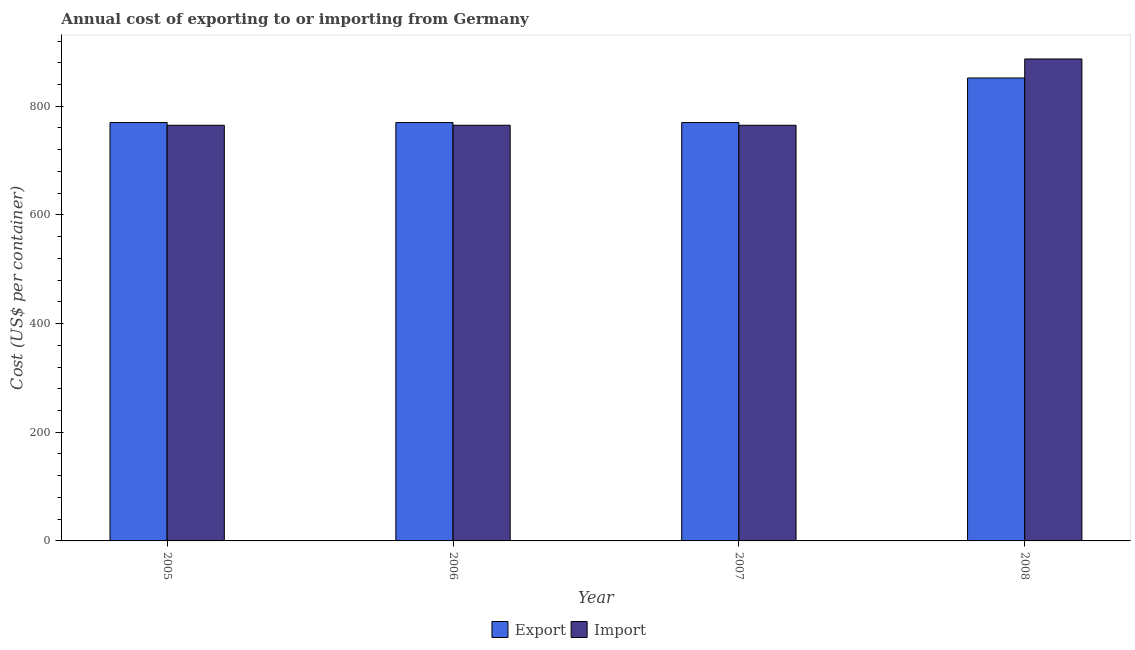Are the number of bars per tick equal to the number of legend labels?
Provide a short and direct response. Yes. What is the label of the 3rd group of bars from the left?
Offer a very short reply. 2007. What is the import cost in 2005?
Provide a succinct answer. 765. Across all years, what is the maximum export cost?
Offer a terse response. 852. Across all years, what is the minimum export cost?
Give a very brief answer. 770. In which year was the export cost minimum?
Give a very brief answer. 2005. What is the total import cost in the graph?
Ensure brevity in your answer.  3182. What is the difference between the export cost in 2005 and that in 2008?
Your response must be concise. -82. What is the difference between the export cost in 2008 and the import cost in 2007?
Provide a short and direct response. 82. What is the average import cost per year?
Provide a succinct answer. 795.5. In how many years, is the import cost greater than 520 US$?
Offer a very short reply. 4. What is the ratio of the export cost in 2006 to that in 2008?
Your answer should be compact. 0.9. What is the difference between the highest and the second highest import cost?
Your answer should be very brief. 122. What is the difference between the highest and the lowest import cost?
Provide a short and direct response. 122. In how many years, is the export cost greater than the average export cost taken over all years?
Offer a very short reply. 1. What does the 1st bar from the left in 2008 represents?
Give a very brief answer. Export. What does the 1st bar from the right in 2008 represents?
Give a very brief answer. Import. How many bars are there?
Give a very brief answer. 8. What is the difference between two consecutive major ticks on the Y-axis?
Your answer should be compact. 200. Does the graph contain grids?
Your answer should be very brief. No. What is the title of the graph?
Provide a short and direct response. Annual cost of exporting to or importing from Germany. Does "Lowest 20% of population" appear as one of the legend labels in the graph?
Provide a short and direct response. No. What is the label or title of the X-axis?
Keep it short and to the point. Year. What is the label or title of the Y-axis?
Provide a succinct answer. Cost (US$ per container). What is the Cost (US$ per container) in Export in 2005?
Keep it short and to the point. 770. What is the Cost (US$ per container) in Import in 2005?
Offer a terse response. 765. What is the Cost (US$ per container) of Export in 2006?
Make the answer very short. 770. What is the Cost (US$ per container) of Import in 2006?
Provide a short and direct response. 765. What is the Cost (US$ per container) of Export in 2007?
Keep it short and to the point. 770. What is the Cost (US$ per container) in Import in 2007?
Keep it short and to the point. 765. What is the Cost (US$ per container) of Export in 2008?
Give a very brief answer. 852. What is the Cost (US$ per container) in Import in 2008?
Offer a terse response. 887. Across all years, what is the maximum Cost (US$ per container) of Export?
Provide a short and direct response. 852. Across all years, what is the maximum Cost (US$ per container) of Import?
Provide a succinct answer. 887. Across all years, what is the minimum Cost (US$ per container) of Export?
Offer a very short reply. 770. Across all years, what is the minimum Cost (US$ per container) in Import?
Your response must be concise. 765. What is the total Cost (US$ per container) of Export in the graph?
Keep it short and to the point. 3162. What is the total Cost (US$ per container) of Import in the graph?
Make the answer very short. 3182. What is the difference between the Cost (US$ per container) of Export in 2005 and that in 2006?
Ensure brevity in your answer.  0. What is the difference between the Cost (US$ per container) in Import in 2005 and that in 2007?
Offer a very short reply. 0. What is the difference between the Cost (US$ per container) in Export in 2005 and that in 2008?
Make the answer very short. -82. What is the difference between the Cost (US$ per container) of Import in 2005 and that in 2008?
Offer a very short reply. -122. What is the difference between the Cost (US$ per container) in Export in 2006 and that in 2007?
Offer a very short reply. 0. What is the difference between the Cost (US$ per container) in Export in 2006 and that in 2008?
Offer a very short reply. -82. What is the difference between the Cost (US$ per container) in Import in 2006 and that in 2008?
Provide a short and direct response. -122. What is the difference between the Cost (US$ per container) in Export in 2007 and that in 2008?
Ensure brevity in your answer.  -82. What is the difference between the Cost (US$ per container) in Import in 2007 and that in 2008?
Make the answer very short. -122. What is the difference between the Cost (US$ per container) of Export in 2005 and the Cost (US$ per container) of Import in 2007?
Make the answer very short. 5. What is the difference between the Cost (US$ per container) in Export in 2005 and the Cost (US$ per container) in Import in 2008?
Offer a terse response. -117. What is the difference between the Cost (US$ per container) in Export in 2006 and the Cost (US$ per container) in Import in 2007?
Offer a terse response. 5. What is the difference between the Cost (US$ per container) of Export in 2006 and the Cost (US$ per container) of Import in 2008?
Your answer should be very brief. -117. What is the difference between the Cost (US$ per container) of Export in 2007 and the Cost (US$ per container) of Import in 2008?
Provide a short and direct response. -117. What is the average Cost (US$ per container) in Export per year?
Offer a very short reply. 790.5. What is the average Cost (US$ per container) of Import per year?
Offer a terse response. 795.5. In the year 2006, what is the difference between the Cost (US$ per container) in Export and Cost (US$ per container) in Import?
Provide a short and direct response. 5. In the year 2008, what is the difference between the Cost (US$ per container) in Export and Cost (US$ per container) in Import?
Provide a short and direct response. -35. What is the ratio of the Cost (US$ per container) of Export in 2005 to that in 2007?
Offer a very short reply. 1. What is the ratio of the Cost (US$ per container) of Export in 2005 to that in 2008?
Your response must be concise. 0.9. What is the ratio of the Cost (US$ per container) of Import in 2005 to that in 2008?
Give a very brief answer. 0.86. What is the ratio of the Cost (US$ per container) of Export in 2006 to that in 2007?
Provide a short and direct response. 1. What is the ratio of the Cost (US$ per container) in Import in 2006 to that in 2007?
Provide a succinct answer. 1. What is the ratio of the Cost (US$ per container) of Export in 2006 to that in 2008?
Your answer should be very brief. 0.9. What is the ratio of the Cost (US$ per container) of Import in 2006 to that in 2008?
Provide a succinct answer. 0.86. What is the ratio of the Cost (US$ per container) of Export in 2007 to that in 2008?
Provide a short and direct response. 0.9. What is the ratio of the Cost (US$ per container) in Import in 2007 to that in 2008?
Your answer should be very brief. 0.86. What is the difference between the highest and the second highest Cost (US$ per container) of Import?
Offer a very short reply. 122. What is the difference between the highest and the lowest Cost (US$ per container) in Export?
Ensure brevity in your answer.  82. What is the difference between the highest and the lowest Cost (US$ per container) of Import?
Ensure brevity in your answer.  122. 